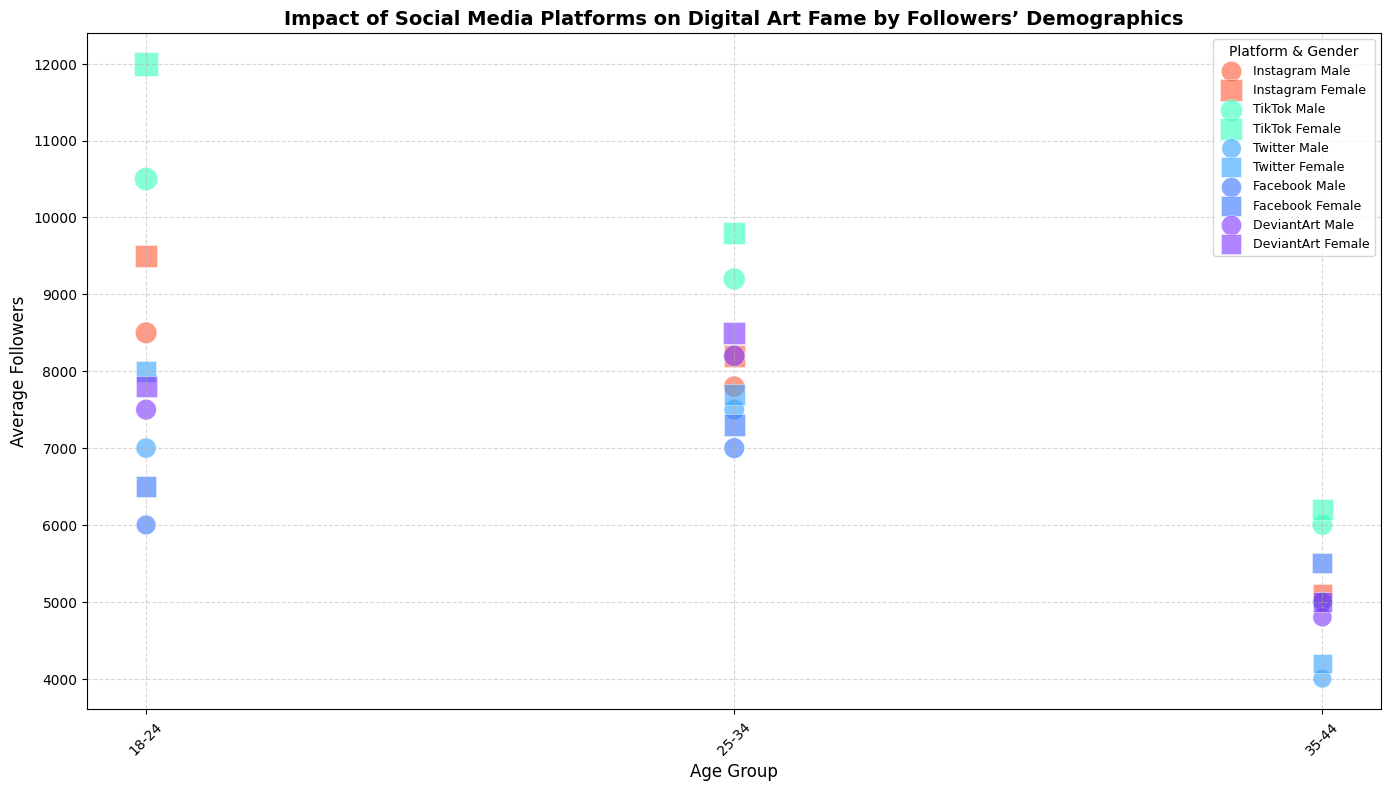Which platform has the highest average followers for the 18-24 age group? Look at the y-axis values for the 18-24 age group and compare the average followers for each platform. TikTok has the highest average followers in this age group.
Answer: TikTok For the 25-34 age group, which gender generally has more followers across all platforms? Compare the average followers for males and females in the 25-34 age group across all platforms. Females have more followers in most platforms such as Instagram, TikTok, Twitter, and Facebook.
Answer: Female How does the average number of followers for 35-44 year old males on Instagram compare to those on Twitter? Find and compare the y-axis values for the 35-44 age group for males on both platforms. The average followers for males on Instagram is higher than on Twitter.
Answer: Higher on Instagram Which age group on Facebook has the smallest bubble size? Compare the bubble sizes for each age group on Facebook by looking at the plotted points. The age group 18-24 has the smallest bubble size on Facebook.
Answer: 18-24 What is the difference in average followers between males and females in the 18-24 age group on TikTok? Subtract the average followers of males from females in the 18-24 age group on TikTok. The difference is 12000 - 10500 = 1500.
Answer: 1500 Which platform and gender combination has the highest bubble size in the 25-34 age group? Compare the bubble sizes for each platform and gender combination in the 25-34 age group. TikTok female has the highest bubble size.
Answer: TikTok female What conclusion can you draw about the popularity of digital art on Instagram for different age groups? Observe the general trend of average followers across different age groups on Instagram. The average followers decrease as the age group increases, suggesting that Instagram is more popular among younger users.
Answer: More popular among younger users For the 35-44 age group, are there more followers on Facebook or DeviantArt for females? Compare the y-axis values for females in the 35-44 age group for both platforms. DeviantArt has fewer followers compared to Facebook.
Answer: Facebook How are the bubble sizes for the 18-24 age group different for TikTok and Instagram for both genders? Compare the bubble sizes for both males and females in the 18-24 age group for TikTok and Instagram. TikTok bubbles are larger than Instagram bubbles for both genders.
Answer: Larger on TikTok 